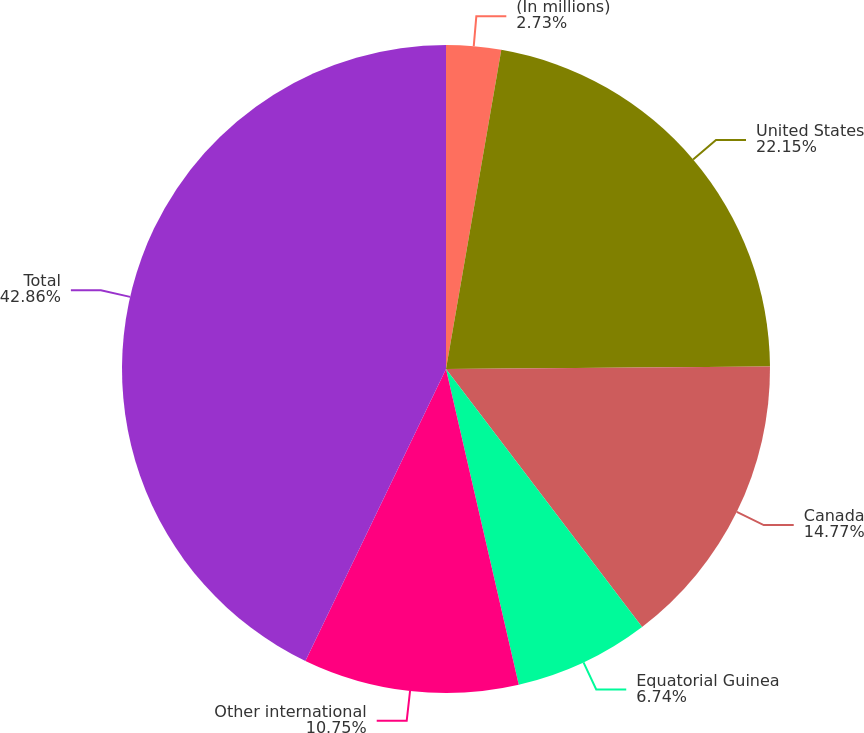<chart> <loc_0><loc_0><loc_500><loc_500><pie_chart><fcel>(In millions)<fcel>United States<fcel>Canada<fcel>Equatorial Guinea<fcel>Other international<fcel>Total<nl><fcel>2.73%<fcel>22.15%<fcel>14.77%<fcel>6.74%<fcel>10.75%<fcel>42.85%<nl></chart> 